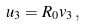Convert formula to latex. <formula><loc_0><loc_0><loc_500><loc_500>u _ { 3 } = R _ { 0 } v _ { 3 } \, ,</formula> 